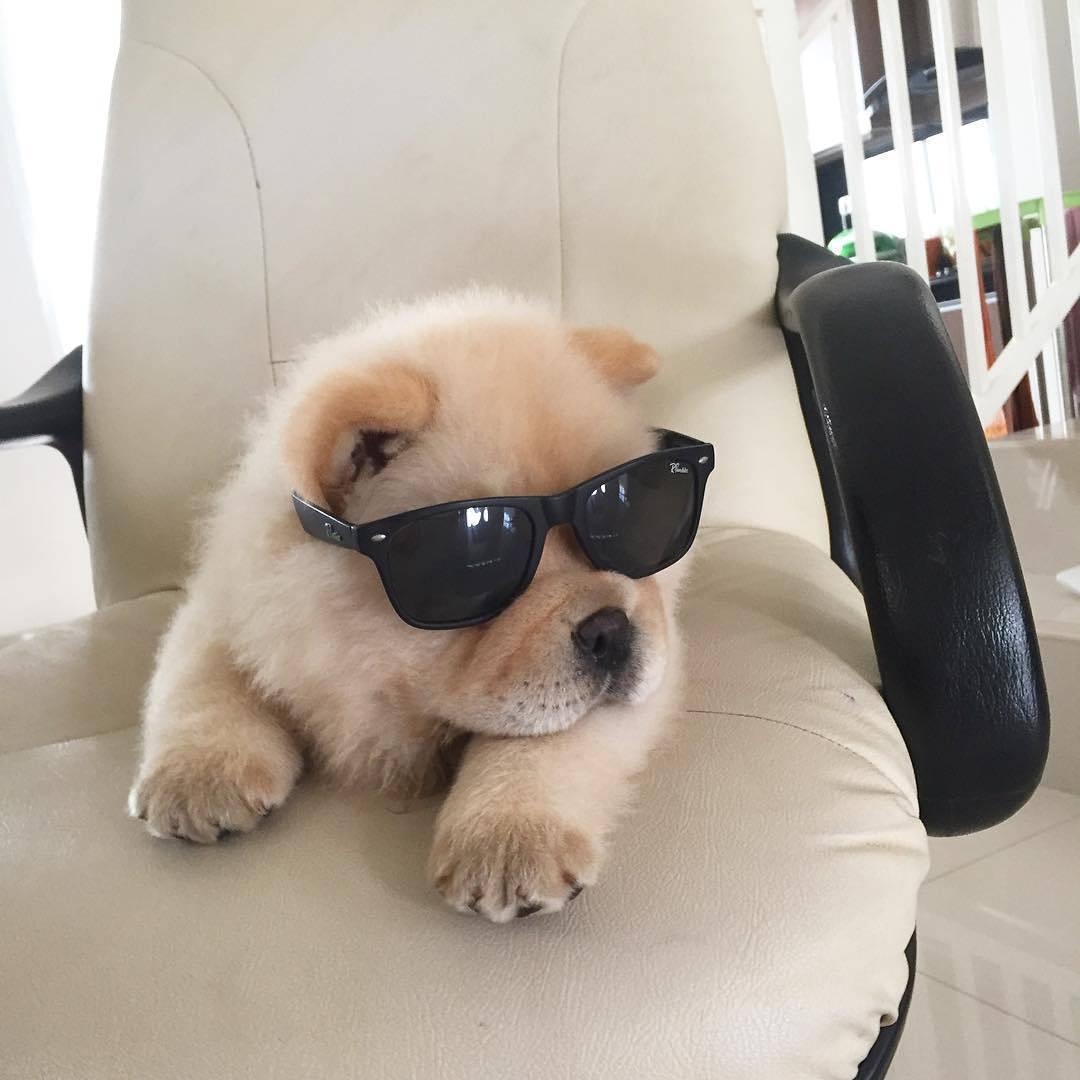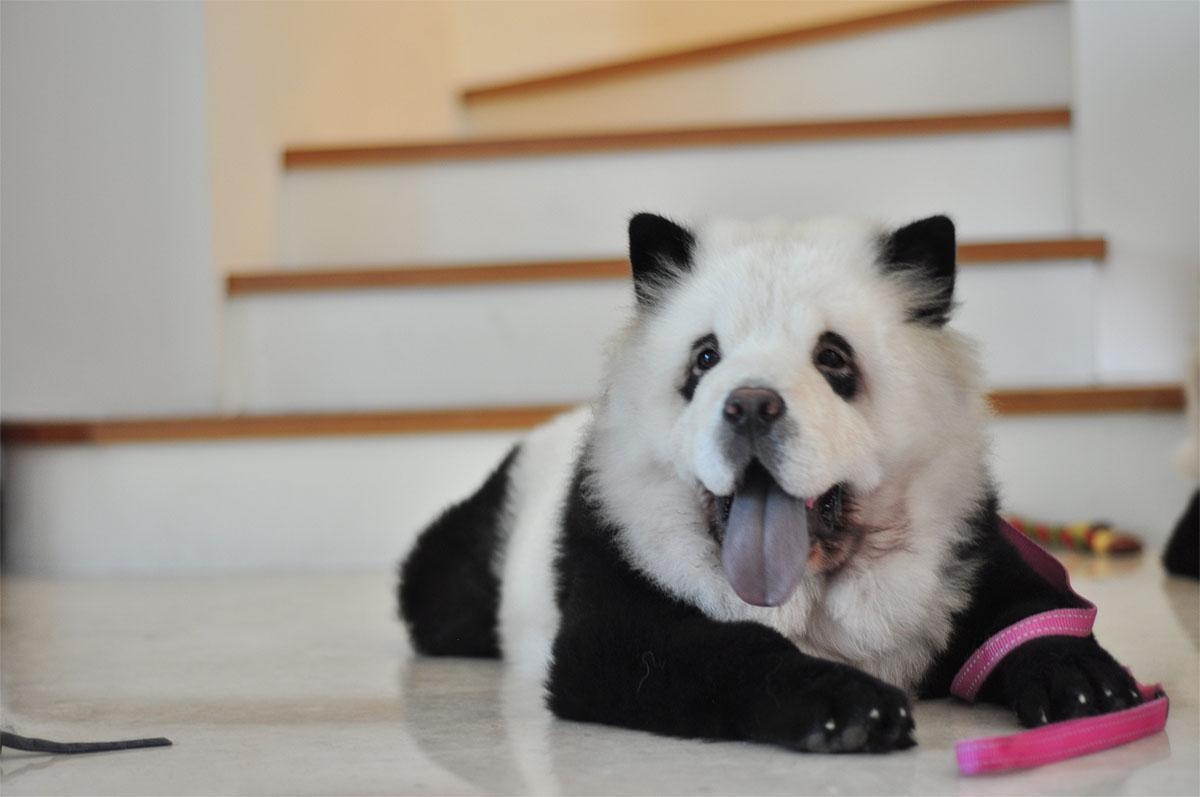The first image is the image on the left, the second image is the image on the right. Given the left and right images, does the statement "A woman is hugging dogs dyes to look like pandas" hold true? Answer yes or no. No. The first image is the image on the left, the second image is the image on the right. Assess this claim about the two images: "In one image, a woman poses with three dogs". Correct or not? Answer yes or no. No. 